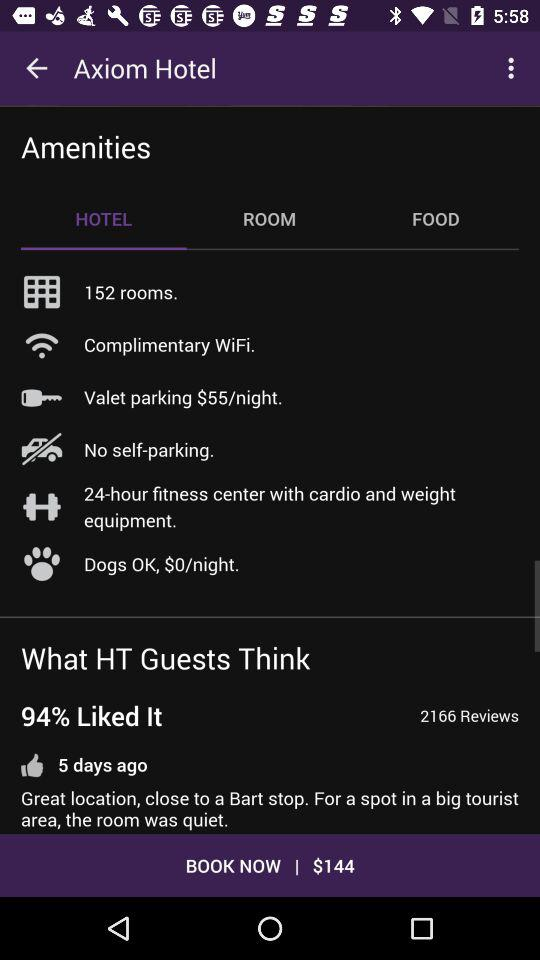How many rooms are there? There are 152 rooms. 